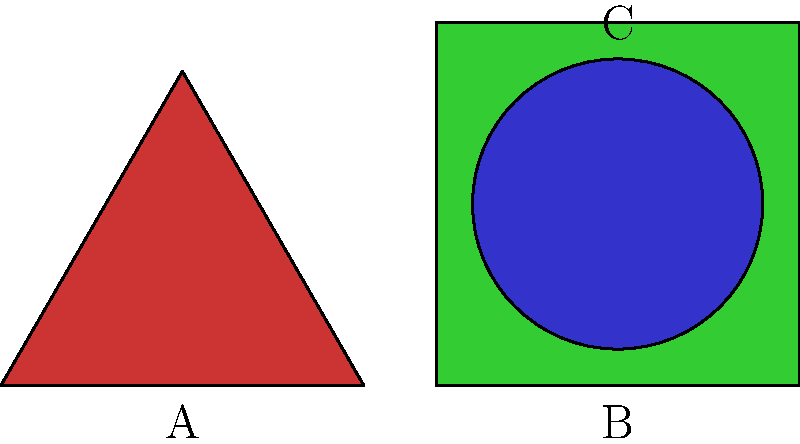In the abstract art piece above, which shape is most likely to evoke feelings of stability and balance, and why might this be significant from a psychological perspective? To answer this question, we need to consider the psychological impact of different shapes:

1. Triangle (A): 
   - Sharp angles can create tension or dynamism
   - Pointing upward, it might suggest aspiration or growth
   - However, it's less stable due to its narrow base

2. Square (B):
   - Equal sides and right angles create a sense of stability and order
   - Represents structure, foundation, and reliability
   - In many cultures, associated with earthly elements and grounding

3. Circle (C):
   - Absence of angles creates a sense of harmony and completeness
   - Can represent unity or infinity
   - However, it might be perceived as less grounded than the square

From a psychological perspective, the square (B) is most likely to evoke feelings of stability and balance. This is significant because:

1. Environmental psychology suggests that shapes in our surroundings can influence our mental state
2. The stability represented by the square can induce feelings of security and calmness
3. In therapy settings, stable and balanced visual elements might help create a safe and contained environment for clients
4. Understanding shape perception can aid in designing spaces that promote specific psychological states (e.g., relaxation areas in hospitals)
5. In art therapy, the use of squares might be encouraged when working with clients who need to feel more grounded or stable

The impact of shapes on mood and perception is an important aspect of environmental psychology and can be applied in various therapeutic and design contexts.
Answer: The square (B), evoking stability and balance through equal sides and right angles, significant for its calming psychological impact. 